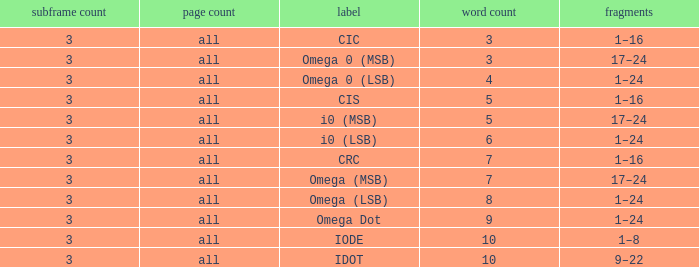What is the total word count with a subframe count greater than 3? None. 